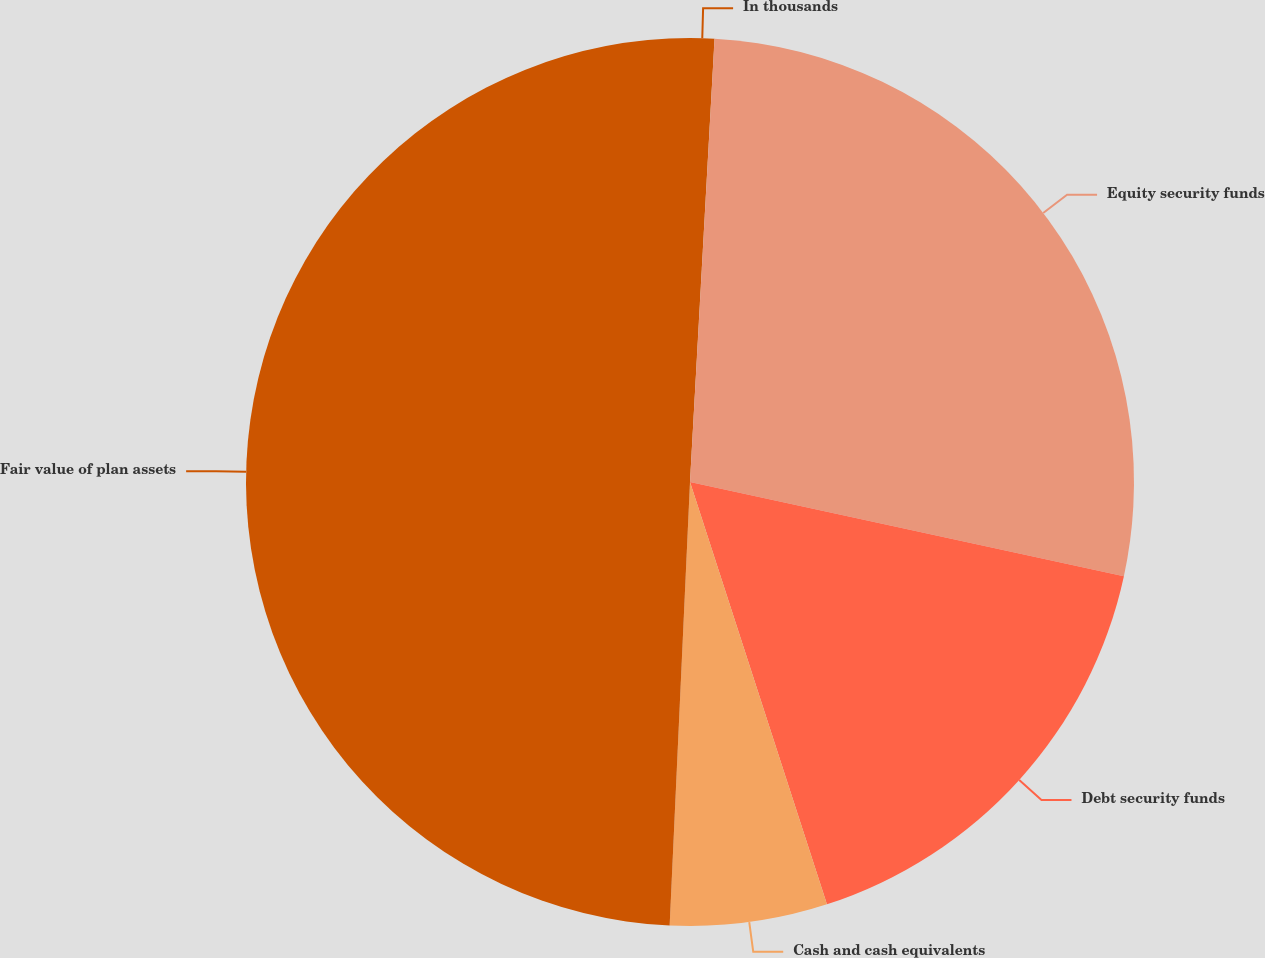Convert chart to OTSL. <chart><loc_0><loc_0><loc_500><loc_500><pie_chart><fcel>In thousands<fcel>Equity security funds<fcel>Debt security funds<fcel>Cash and cash equivalents<fcel>Fair value of plan assets<nl><fcel>0.88%<fcel>27.52%<fcel>16.61%<fcel>5.72%<fcel>49.27%<nl></chart> 